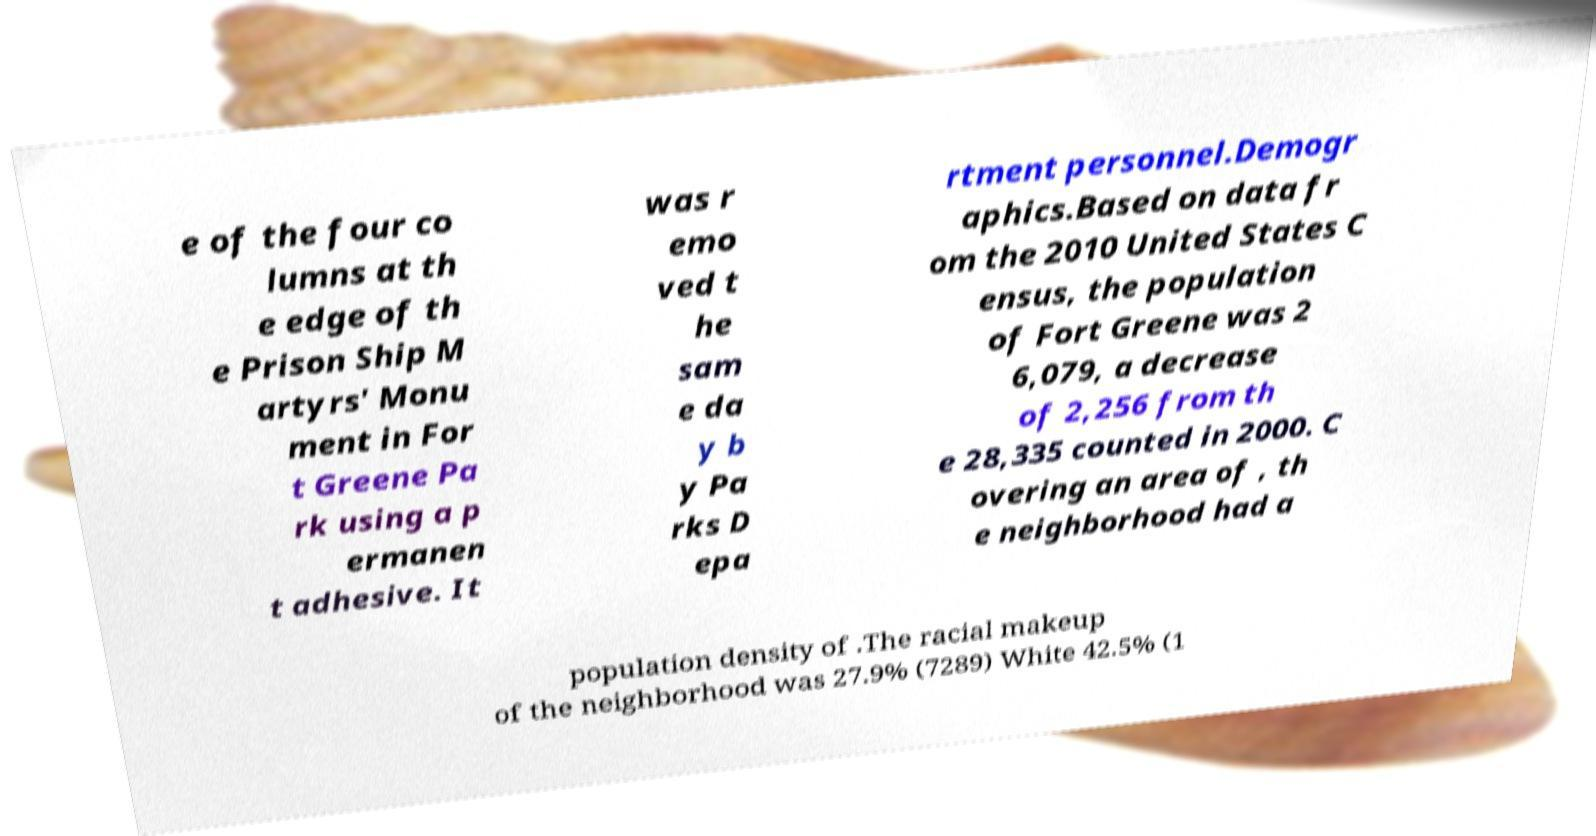There's text embedded in this image that I need extracted. Can you transcribe it verbatim? e of the four co lumns at th e edge of th e Prison Ship M artyrs' Monu ment in For t Greene Pa rk using a p ermanen t adhesive. It was r emo ved t he sam e da y b y Pa rks D epa rtment personnel.Demogr aphics.Based on data fr om the 2010 United States C ensus, the population of Fort Greene was 2 6,079, a decrease of 2,256 from th e 28,335 counted in 2000. C overing an area of , th e neighborhood had a population density of .The racial makeup of the neighborhood was 27.9% (7289) White 42.5% (1 